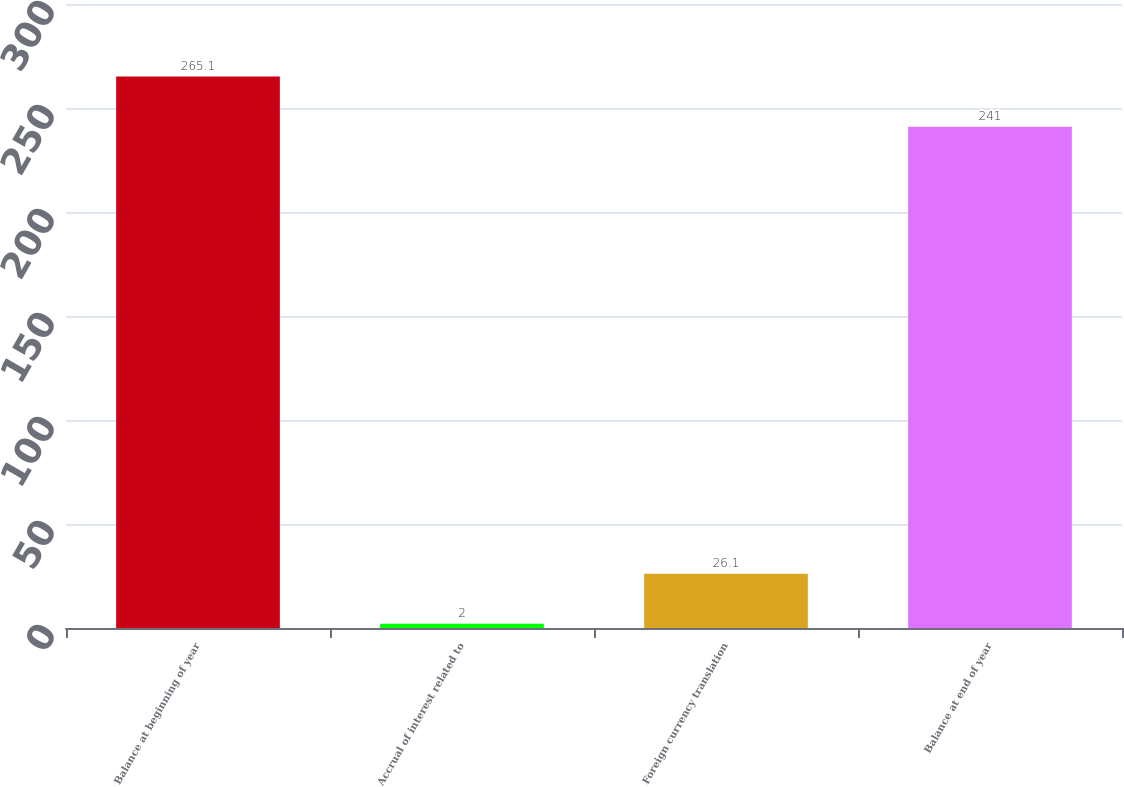Convert chart to OTSL. <chart><loc_0><loc_0><loc_500><loc_500><bar_chart><fcel>Balance at beginning of year<fcel>Accrual of interest related to<fcel>Foreign currency translation<fcel>Balance at end of year<nl><fcel>265.1<fcel>2<fcel>26.1<fcel>241<nl></chart> 